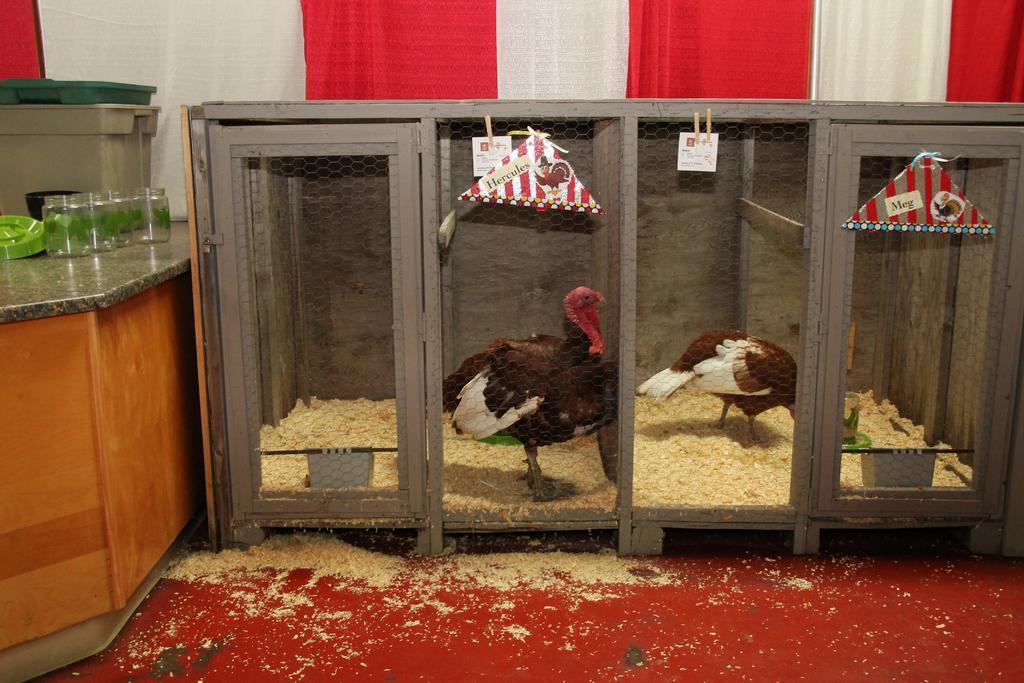Describe this image in one or two sentences. In this image we can see birds in the cage and there is a cabinet beside the cage. On the cabinet we can see organizers and pet jars. In the background there is a curtain. 